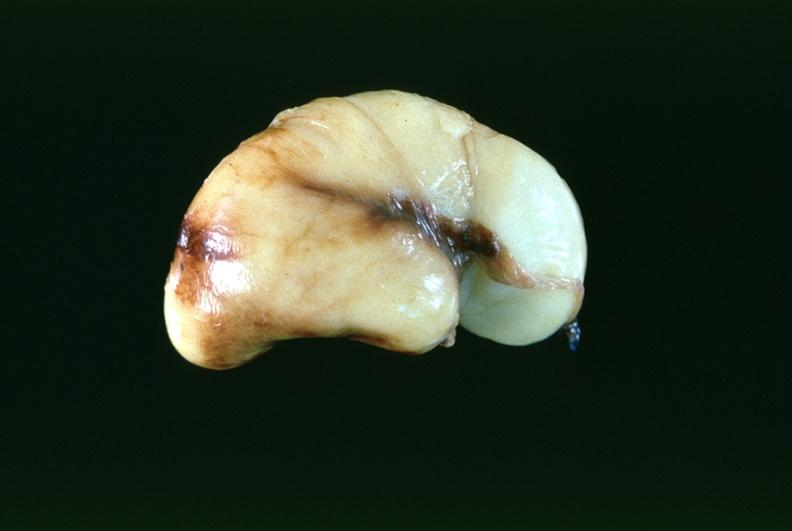does this image show brain, intraventricular hemmorrhage in a prematue baby with hyaline membrane disease?
Answer the question using a single word or phrase. Yes 